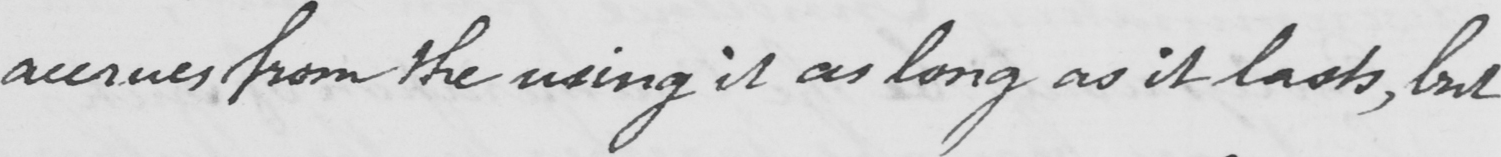Can you read and transcribe this handwriting? accrues from the using it as long as it lasts , but 